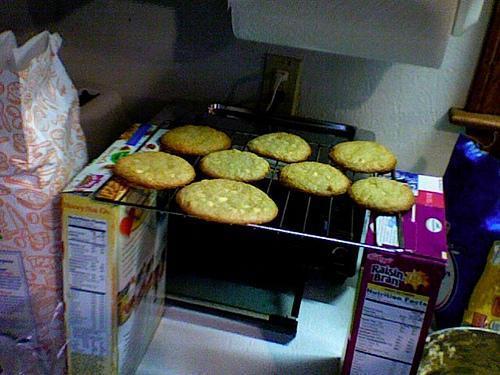How many cookies are in the photo?
Give a very brief answer. 8. 